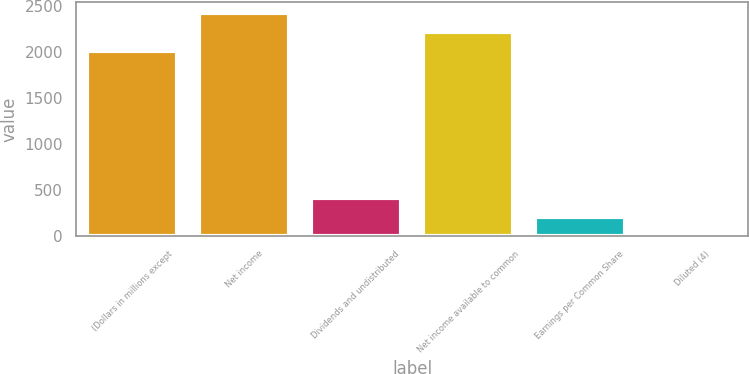Convert chart. <chart><loc_0><loc_0><loc_500><loc_500><bar_chart><fcel>(Dollars in millions except<fcel>Net income<fcel>Dividends and undistributed<fcel>Net income available to common<fcel>Earnings per Common Share<fcel>Diluted (4)<nl><fcel>2012<fcel>2423.36<fcel>415.56<fcel>2217.68<fcel>209.88<fcel>4.2<nl></chart> 